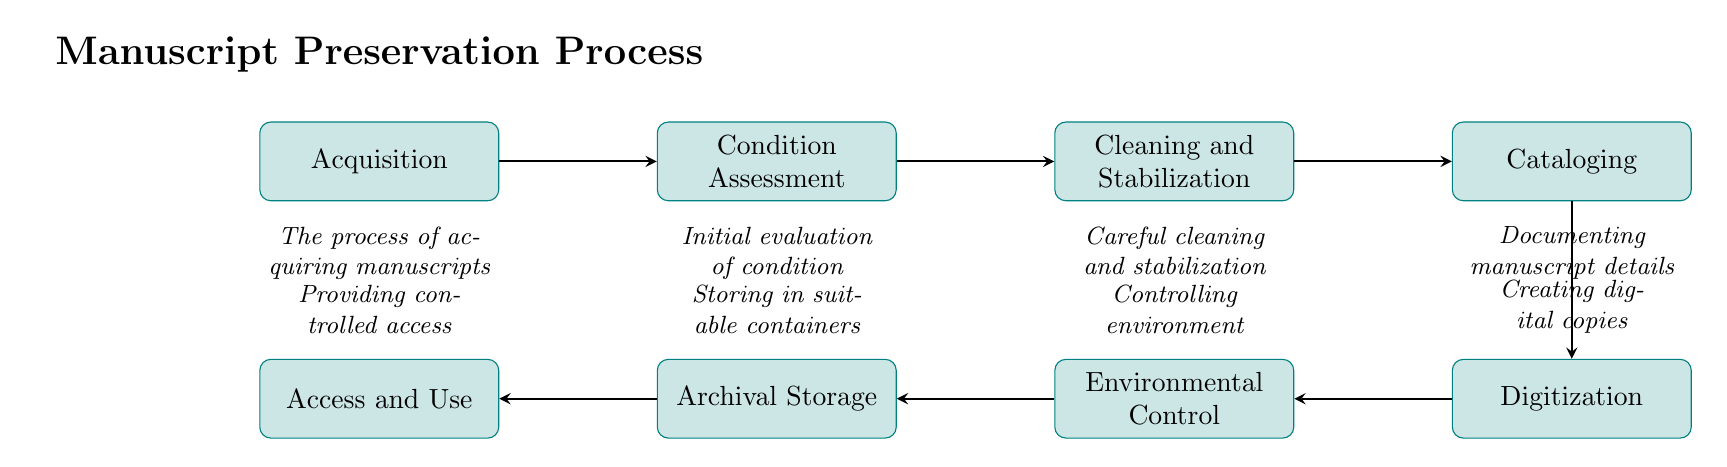What is the first step in the manuscript preservation process? The first node in the flow chart is "Acquisition," which is the initial step in the manuscript preservation process.
Answer: Acquisition How many nodes are in the diagram? By counting all the listed nodes in the diagram, we find there are eight distinct nodes representing different steps in the process.
Answer: 8 What follows after "Condition Assessment"? The process moves to the next step indicated by the arrow, which is "Cleaning and Stabilization," following the evaluation of the manuscript's condition.
Answer: Cleaning and Stabilization Which step involves creating digital copies? The "Digitization" node specifically refers to the process of creating high-resolution digital copies of the manuscripts, as indicated in the flow chart.
Answer: Digitization What is the final step in the preservation process? The last node in the diagram is "Access and Use," which is the final stage where manuscripts are made accessible to researchers and the public while ensuring their preservation.
Answer: Access and Use How is "Environmental Control" positioned relative to "Digitization"? "Environmental Control" is located directly to the left of "Digitization," indicating that it follows the digitization process in sequence.
Answer: Left of What action is taken after "Cataloging"? Once cataloging is completed, the flow chart indicates that the next step is "Digitization," meaning digital copies are created following the documentation of the manuscripts.
Answer: Digitization Which step comes before "Archival Storage"? The process leading up to "Archival Storage" involves "Environmental Control," which focuses on maintaining the appropriate conditions for the stored manuscripts.
Answer: Environmental Control What is the action described in "Cleaning and Stabilization"? The node "Cleaning and Stabilization" describes the careful cleaning and stabilization processes necessary for preventing further deterioration of the manuscripts.
Answer: Careful cleaning and stabilization 